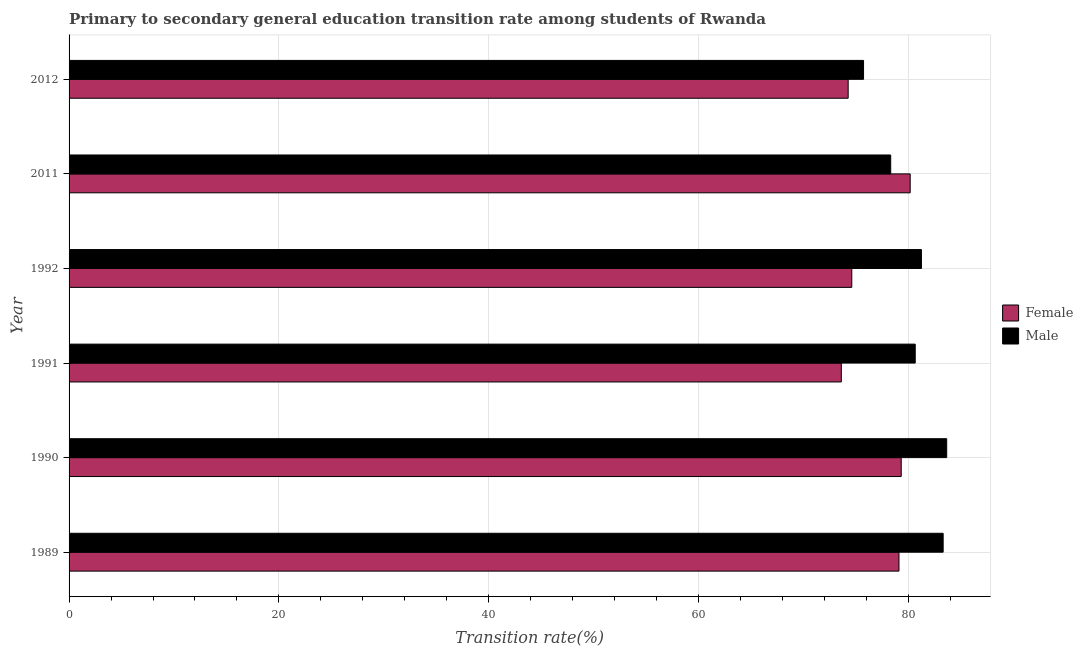How many groups of bars are there?
Your answer should be very brief. 6. Are the number of bars per tick equal to the number of legend labels?
Give a very brief answer. Yes. How many bars are there on the 1st tick from the bottom?
Your response must be concise. 2. What is the label of the 2nd group of bars from the top?
Make the answer very short. 2011. What is the transition rate among female students in 1992?
Offer a terse response. 74.61. Across all years, what is the maximum transition rate among female students?
Give a very brief answer. 80.17. Across all years, what is the minimum transition rate among female students?
Ensure brevity in your answer.  73.61. In which year was the transition rate among male students maximum?
Ensure brevity in your answer.  1990. In which year was the transition rate among female students minimum?
Provide a succinct answer. 1991. What is the total transition rate among female students in the graph?
Your response must be concise. 461.08. What is the difference between the transition rate among female students in 2011 and that in 2012?
Make the answer very short. 5.91. What is the difference between the transition rate among male students in 1990 and the transition rate among female students in 1992?
Make the answer very short. 9.05. What is the average transition rate among female students per year?
Your answer should be compact. 76.85. In the year 1991, what is the difference between the transition rate among female students and transition rate among male students?
Give a very brief answer. -7.05. Is the transition rate among male students in 1991 less than that in 1992?
Your answer should be compact. Yes. Is the difference between the transition rate among female students in 1990 and 1991 greater than the difference between the transition rate among male students in 1990 and 1991?
Provide a short and direct response. Yes. What is the difference between the highest and the second highest transition rate among male students?
Your answer should be compact. 0.34. What is the difference between the highest and the lowest transition rate among male students?
Your response must be concise. 7.93. Is the sum of the transition rate among female students in 1991 and 2011 greater than the maximum transition rate among male students across all years?
Keep it short and to the point. Yes. What does the 2nd bar from the top in 1992 represents?
Provide a short and direct response. Female. What does the 1st bar from the bottom in 1991 represents?
Offer a terse response. Female. How many bars are there?
Your answer should be compact. 12. Are all the bars in the graph horizontal?
Ensure brevity in your answer.  Yes. What is the difference between two consecutive major ticks on the X-axis?
Your answer should be compact. 20. Does the graph contain grids?
Offer a very short reply. Yes. Where does the legend appear in the graph?
Your response must be concise. Center right. What is the title of the graph?
Keep it short and to the point. Primary to secondary general education transition rate among students of Rwanda. Does "Personal remittances" appear as one of the legend labels in the graph?
Your answer should be very brief. No. What is the label or title of the X-axis?
Make the answer very short. Transition rate(%). What is the label or title of the Y-axis?
Provide a succinct answer. Year. What is the Transition rate(%) of Female in 1989?
Ensure brevity in your answer.  79.11. What is the Transition rate(%) in Male in 1989?
Offer a terse response. 83.32. What is the Transition rate(%) of Female in 1990?
Give a very brief answer. 79.32. What is the Transition rate(%) in Male in 1990?
Your answer should be very brief. 83.66. What is the Transition rate(%) in Female in 1991?
Offer a very short reply. 73.61. What is the Transition rate(%) in Male in 1991?
Provide a succinct answer. 80.66. What is the Transition rate(%) in Female in 1992?
Your answer should be compact. 74.61. What is the Transition rate(%) of Male in 1992?
Make the answer very short. 81.25. What is the Transition rate(%) of Female in 2011?
Offer a very short reply. 80.17. What is the Transition rate(%) of Male in 2011?
Offer a terse response. 78.32. What is the Transition rate(%) in Female in 2012?
Your answer should be very brief. 74.26. What is the Transition rate(%) of Male in 2012?
Your answer should be very brief. 75.73. Across all years, what is the maximum Transition rate(%) of Female?
Keep it short and to the point. 80.17. Across all years, what is the maximum Transition rate(%) of Male?
Your response must be concise. 83.66. Across all years, what is the minimum Transition rate(%) of Female?
Keep it short and to the point. 73.61. Across all years, what is the minimum Transition rate(%) of Male?
Your response must be concise. 75.73. What is the total Transition rate(%) in Female in the graph?
Give a very brief answer. 461.08. What is the total Transition rate(%) of Male in the graph?
Your answer should be very brief. 482.92. What is the difference between the Transition rate(%) in Female in 1989 and that in 1990?
Provide a succinct answer. -0.21. What is the difference between the Transition rate(%) in Male in 1989 and that in 1990?
Provide a short and direct response. -0.34. What is the difference between the Transition rate(%) of Female in 1989 and that in 1991?
Offer a very short reply. 5.5. What is the difference between the Transition rate(%) in Male in 1989 and that in 1991?
Ensure brevity in your answer.  2.66. What is the difference between the Transition rate(%) in Female in 1989 and that in 1992?
Your answer should be compact. 4.5. What is the difference between the Transition rate(%) in Male in 1989 and that in 1992?
Give a very brief answer. 2.07. What is the difference between the Transition rate(%) of Female in 1989 and that in 2011?
Provide a short and direct response. -1.07. What is the difference between the Transition rate(%) of Male in 1989 and that in 2011?
Offer a terse response. 5. What is the difference between the Transition rate(%) of Female in 1989 and that in 2012?
Your answer should be very brief. 4.84. What is the difference between the Transition rate(%) of Male in 1989 and that in 2012?
Your answer should be compact. 7.59. What is the difference between the Transition rate(%) of Female in 1990 and that in 1991?
Keep it short and to the point. 5.71. What is the difference between the Transition rate(%) of Male in 1990 and that in 1991?
Provide a succinct answer. 3. What is the difference between the Transition rate(%) in Female in 1990 and that in 1992?
Offer a very short reply. 4.71. What is the difference between the Transition rate(%) in Male in 1990 and that in 1992?
Make the answer very short. 2.41. What is the difference between the Transition rate(%) in Female in 1990 and that in 2011?
Give a very brief answer. -0.85. What is the difference between the Transition rate(%) of Male in 1990 and that in 2011?
Your answer should be very brief. 5.34. What is the difference between the Transition rate(%) in Female in 1990 and that in 2012?
Keep it short and to the point. 5.06. What is the difference between the Transition rate(%) in Male in 1990 and that in 2012?
Your response must be concise. 7.93. What is the difference between the Transition rate(%) in Female in 1991 and that in 1992?
Give a very brief answer. -1. What is the difference between the Transition rate(%) of Male in 1991 and that in 1992?
Provide a short and direct response. -0.59. What is the difference between the Transition rate(%) of Female in 1991 and that in 2011?
Your answer should be very brief. -6.57. What is the difference between the Transition rate(%) in Male in 1991 and that in 2011?
Provide a short and direct response. 2.34. What is the difference between the Transition rate(%) of Female in 1991 and that in 2012?
Provide a succinct answer. -0.65. What is the difference between the Transition rate(%) of Male in 1991 and that in 2012?
Offer a very short reply. 4.93. What is the difference between the Transition rate(%) in Female in 1992 and that in 2011?
Offer a terse response. -5.57. What is the difference between the Transition rate(%) of Male in 1992 and that in 2011?
Keep it short and to the point. 2.93. What is the difference between the Transition rate(%) of Female in 1992 and that in 2012?
Your response must be concise. 0.34. What is the difference between the Transition rate(%) in Male in 1992 and that in 2012?
Provide a short and direct response. 5.52. What is the difference between the Transition rate(%) in Female in 2011 and that in 2012?
Make the answer very short. 5.91. What is the difference between the Transition rate(%) of Male in 2011 and that in 2012?
Make the answer very short. 2.59. What is the difference between the Transition rate(%) of Female in 1989 and the Transition rate(%) of Male in 1990?
Provide a short and direct response. -4.55. What is the difference between the Transition rate(%) of Female in 1989 and the Transition rate(%) of Male in 1991?
Your response must be concise. -1.55. What is the difference between the Transition rate(%) in Female in 1989 and the Transition rate(%) in Male in 1992?
Provide a short and direct response. -2.14. What is the difference between the Transition rate(%) of Female in 1989 and the Transition rate(%) of Male in 2011?
Make the answer very short. 0.79. What is the difference between the Transition rate(%) in Female in 1989 and the Transition rate(%) in Male in 2012?
Give a very brief answer. 3.38. What is the difference between the Transition rate(%) in Female in 1990 and the Transition rate(%) in Male in 1991?
Ensure brevity in your answer.  -1.34. What is the difference between the Transition rate(%) in Female in 1990 and the Transition rate(%) in Male in 1992?
Provide a succinct answer. -1.93. What is the difference between the Transition rate(%) of Female in 1990 and the Transition rate(%) of Male in 2011?
Your answer should be very brief. 1. What is the difference between the Transition rate(%) of Female in 1990 and the Transition rate(%) of Male in 2012?
Provide a succinct answer. 3.59. What is the difference between the Transition rate(%) in Female in 1991 and the Transition rate(%) in Male in 1992?
Make the answer very short. -7.64. What is the difference between the Transition rate(%) in Female in 1991 and the Transition rate(%) in Male in 2011?
Provide a succinct answer. -4.71. What is the difference between the Transition rate(%) in Female in 1991 and the Transition rate(%) in Male in 2012?
Provide a succinct answer. -2.12. What is the difference between the Transition rate(%) of Female in 1992 and the Transition rate(%) of Male in 2011?
Make the answer very short. -3.71. What is the difference between the Transition rate(%) of Female in 1992 and the Transition rate(%) of Male in 2012?
Your answer should be very brief. -1.12. What is the difference between the Transition rate(%) of Female in 2011 and the Transition rate(%) of Male in 2012?
Keep it short and to the point. 4.45. What is the average Transition rate(%) of Female per year?
Provide a short and direct response. 76.85. What is the average Transition rate(%) in Male per year?
Give a very brief answer. 80.49. In the year 1989, what is the difference between the Transition rate(%) in Female and Transition rate(%) in Male?
Keep it short and to the point. -4.21. In the year 1990, what is the difference between the Transition rate(%) of Female and Transition rate(%) of Male?
Provide a short and direct response. -4.34. In the year 1991, what is the difference between the Transition rate(%) of Female and Transition rate(%) of Male?
Ensure brevity in your answer.  -7.05. In the year 1992, what is the difference between the Transition rate(%) in Female and Transition rate(%) in Male?
Ensure brevity in your answer.  -6.64. In the year 2011, what is the difference between the Transition rate(%) in Female and Transition rate(%) in Male?
Offer a terse response. 1.86. In the year 2012, what is the difference between the Transition rate(%) in Female and Transition rate(%) in Male?
Provide a succinct answer. -1.46. What is the ratio of the Transition rate(%) of Female in 1989 to that in 1990?
Offer a terse response. 1. What is the ratio of the Transition rate(%) in Female in 1989 to that in 1991?
Your response must be concise. 1.07. What is the ratio of the Transition rate(%) in Male in 1989 to that in 1991?
Provide a short and direct response. 1.03. What is the ratio of the Transition rate(%) in Female in 1989 to that in 1992?
Give a very brief answer. 1.06. What is the ratio of the Transition rate(%) in Male in 1989 to that in 1992?
Ensure brevity in your answer.  1.03. What is the ratio of the Transition rate(%) in Female in 1989 to that in 2011?
Your response must be concise. 0.99. What is the ratio of the Transition rate(%) in Male in 1989 to that in 2011?
Your answer should be very brief. 1.06. What is the ratio of the Transition rate(%) in Female in 1989 to that in 2012?
Your response must be concise. 1.07. What is the ratio of the Transition rate(%) in Male in 1989 to that in 2012?
Make the answer very short. 1.1. What is the ratio of the Transition rate(%) in Female in 1990 to that in 1991?
Your answer should be very brief. 1.08. What is the ratio of the Transition rate(%) in Male in 1990 to that in 1991?
Keep it short and to the point. 1.04. What is the ratio of the Transition rate(%) of Female in 1990 to that in 1992?
Your response must be concise. 1.06. What is the ratio of the Transition rate(%) of Male in 1990 to that in 1992?
Your response must be concise. 1.03. What is the ratio of the Transition rate(%) of Female in 1990 to that in 2011?
Provide a succinct answer. 0.99. What is the ratio of the Transition rate(%) of Male in 1990 to that in 2011?
Keep it short and to the point. 1.07. What is the ratio of the Transition rate(%) in Female in 1990 to that in 2012?
Provide a short and direct response. 1.07. What is the ratio of the Transition rate(%) in Male in 1990 to that in 2012?
Give a very brief answer. 1.1. What is the ratio of the Transition rate(%) in Female in 1991 to that in 1992?
Provide a short and direct response. 0.99. What is the ratio of the Transition rate(%) in Female in 1991 to that in 2011?
Provide a succinct answer. 0.92. What is the ratio of the Transition rate(%) of Male in 1991 to that in 2011?
Provide a succinct answer. 1.03. What is the ratio of the Transition rate(%) in Female in 1991 to that in 2012?
Your response must be concise. 0.99. What is the ratio of the Transition rate(%) of Male in 1991 to that in 2012?
Provide a succinct answer. 1.07. What is the ratio of the Transition rate(%) of Female in 1992 to that in 2011?
Keep it short and to the point. 0.93. What is the ratio of the Transition rate(%) in Male in 1992 to that in 2011?
Offer a very short reply. 1.04. What is the ratio of the Transition rate(%) of Female in 1992 to that in 2012?
Your answer should be very brief. 1. What is the ratio of the Transition rate(%) of Male in 1992 to that in 2012?
Provide a short and direct response. 1.07. What is the ratio of the Transition rate(%) in Female in 2011 to that in 2012?
Keep it short and to the point. 1.08. What is the ratio of the Transition rate(%) in Male in 2011 to that in 2012?
Your answer should be very brief. 1.03. What is the difference between the highest and the second highest Transition rate(%) in Female?
Ensure brevity in your answer.  0.85. What is the difference between the highest and the second highest Transition rate(%) in Male?
Your answer should be very brief. 0.34. What is the difference between the highest and the lowest Transition rate(%) in Female?
Offer a very short reply. 6.57. What is the difference between the highest and the lowest Transition rate(%) of Male?
Offer a very short reply. 7.93. 